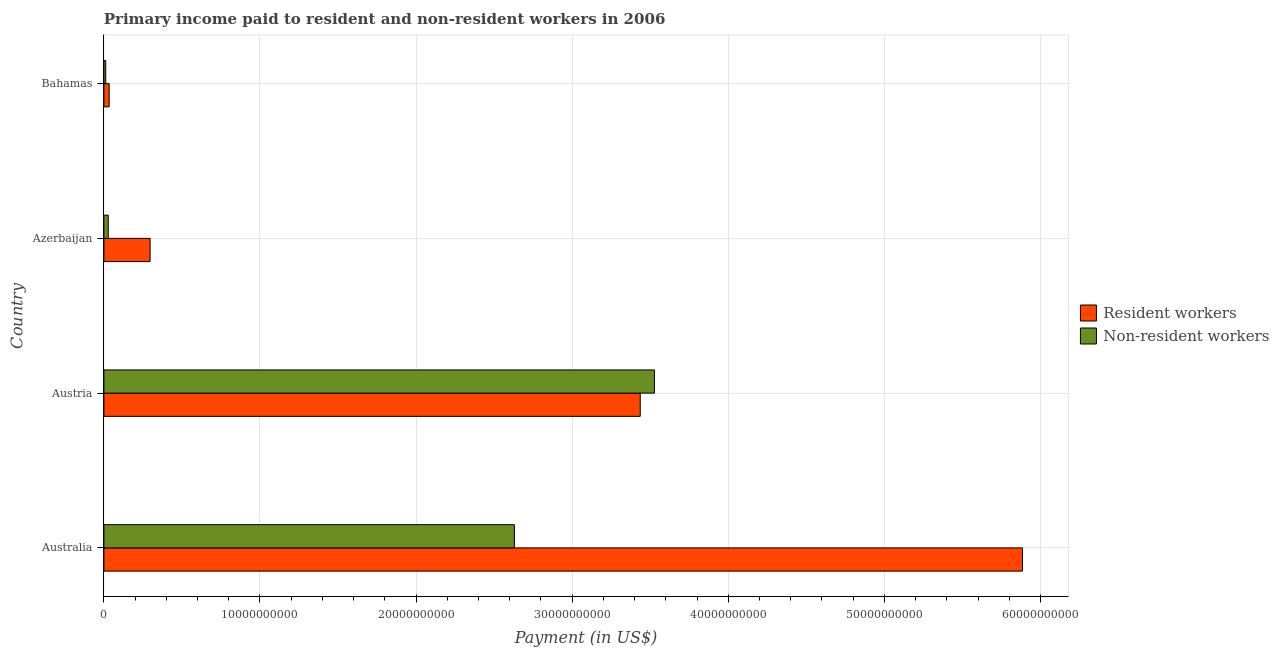Are the number of bars per tick equal to the number of legend labels?
Provide a short and direct response. Yes. How many bars are there on the 2nd tick from the bottom?
Offer a very short reply. 2. What is the label of the 4th group of bars from the top?
Your answer should be very brief. Australia. In how many cases, is the number of bars for a given country not equal to the number of legend labels?
Your answer should be compact. 0. What is the payment made to non-resident workers in Australia?
Your answer should be very brief. 2.63e+1. Across all countries, what is the maximum payment made to resident workers?
Provide a succinct answer. 5.88e+1. Across all countries, what is the minimum payment made to resident workers?
Provide a short and direct response. 3.37e+08. In which country was the payment made to resident workers maximum?
Keep it short and to the point. Australia. In which country was the payment made to resident workers minimum?
Offer a very short reply. Bahamas. What is the total payment made to resident workers in the graph?
Offer a very short reply. 9.65e+1. What is the difference between the payment made to non-resident workers in Australia and that in Austria?
Your answer should be very brief. -8.97e+09. What is the difference between the payment made to resident workers in Australia and the payment made to non-resident workers in Austria?
Your answer should be very brief. 2.36e+1. What is the average payment made to resident workers per country?
Make the answer very short. 2.41e+1. What is the difference between the payment made to resident workers and payment made to non-resident workers in Bahamas?
Provide a short and direct response. 2.18e+08. What is the ratio of the payment made to resident workers in Azerbaijan to that in Bahamas?
Offer a terse response. 8.78. Is the payment made to resident workers in Austria less than that in Azerbaijan?
Keep it short and to the point. No. Is the difference between the payment made to resident workers in Austria and Azerbaijan greater than the difference between the payment made to non-resident workers in Austria and Azerbaijan?
Give a very brief answer. No. What is the difference between the highest and the second highest payment made to resident workers?
Provide a succinct answer. 2.45e+1. What is the difference between the highest and the lowest payment made to non-resident workers?
Provide a succinct answer. 3.52e+1. Is the sum of the payment made to resident workers in Austria and Bahamas greater than the maximum payment made to non-resident workers across all countries?
Offer a terse response. No. What does the 2nd bar from the top in Bahamas represents?
Keep it short and to the point. Resident workers. What does the 1st bar from the bottom in Bahamas represents?
Offer a very short reply. Resident workers. How many bars are there?
Your answer should be compact. 8. Are all the bars in the graph horizontal?
Your answer should be very brief. Yes. How many countries are there in the graph?
Your answer should be compact. 4. What is the difference between two consecutive major ticks on the X-axis?
Make the answer very short. 1.00e+1. Does the graph contain grids?
Give a very brief answer. Yes. Where does the legend appear in the graph?
Offer a terse response. Center right. How are the legend labels stacked?
Keep it short and to the point. Vertical. What is the title of the graph?
Your answer should be compact. Primary income paid to resident and non-resident workers in 2006. Does "Central government" appear as one of the legend labels in the graph?
Offer a very short reply. No. What is the label or title of the X-axis?
Keep it short and to the point. Payment (in US$). What is the Payment (in US$) in Resident workers in Australia?
Offer a very short reply. 5.88e+1. What is the Payment (in US$) in Non-resident workers in Australia?
Give a very brief answer. 2.63e+1. What is the Payment (in US$) of Resident workers in Austria?
Your answer should be very brief. 3.44e+1. What is the Payment (in US$) in Non-resident workers in Austria?
Your answer should be compact. 3.53e+1. What is the Payment (in US$) in Resident workers in Azerbaijan?
Your answer should be very brief. 2.96e+09. What is the Payment (in US$) in Non-resident workers in Azerbaijan?
Your answer should be very brief. 2.80e+08. What is the Payment (in US$) of Resident workers in Bahamas?
Give a very brief answer. 3.37e+08. What is the Payment (in US$) in Non-resident workers in Bahamas?
Your response must be concise. 1.19e+08. Across all countries, what is the maximum Payment (in US$) in Resident workers?
Keep it short and to the point. 5.88e+1. Across all countries, what is the maximum Payment (in US$) in Non-resident workers?
Provide a short and direct response. 3.53e+1. Across all countries, what is the minimum Payment (in US$) of Resident workers?
Provide a succinct answer. 3.37e+08. Across all countries, what is the minimum Payment (in US$) of Non-resident workers?
Your answer should be compact. 1.19e+08. What is the total Payment (in US$) in Resident workers in the graph?
Make the answer very short. 9.65e+1. What is the total Payment (in US$) in Non-resident workers in the graph?
Offer a very short reply. 6.20e+1. What is the difference between the Payment (in US$) of Resident workers in Australia and that in Austria?
Your answer should be compact. 2.45e+1. What is the difference between the Payment (in US$) in Non-resident workers in Australia and that in Austria?
Provide a succinct answer. -8.97e+09. What is the difference between the Payment (in US$) of Resident workers in Australia and that in Azerbaijan?
Offer a very short reply. 5.59e+1. What is the difference between the Payment (in US$) of Non-resident workers in Australia and that in Azerbaijan?
Your response must be concise. 2.60e+1. What is the difference between the Payment (in US$) in Resident workers in Australia and that in Bahamas?
Provide a short and direct response. 5.85e+1. What is the difference between the Payment (in US$) of Non-resident workers in Australia and that in Bahamas?
Offer a very short reply. 2.62e+1. What is the difference between the Payment (in US$) of Resident workers in Austria and that in Azerbaijan?
Provide a succinct answer. 3.14e+1. What is the difference between the Payment (in US$) in Non-resident workers in Austria and that in Azerbaijan?
Make the answer very short. 3.50e+1. What is the difference between the Payment (in US$) in Resident workers in Austria and that in Bahamas?
Make the answer very short. 3.40e+1. What is the difference between the Payment (in US$) in Non-resident workers in Austria and that in Bahamas?
Ensure brevity in your answer.  3.52e+1. What is the difference between the Payment (in US$) in Resident workers in Azerbaijan and that in Bahamas?
Offer a terse response. 2.62e+09. What is the difference between the Payment (in US$) in Non-resident workers in Azerbaijan and that in Bahamas?
Ensure brevity in your answer.  1.61e+08. What is the difference between the Payment (in US$) of Resident workers in Australia and the Payment (in US$) of Non-resident workers in Austria?
Make the answer very short. 2.36e+1. What is the difference between the Payment (in US$) of Resident workers in Australia and the Payment (in US$) of Non-resident workers in Azerbaijan?
Provide a short and direct response. 5.86e+1. What is the difference between the Payment (in US$) in Resident workers in Australia and the Payment (in US$) in Non-resident workers in Bahamas?
Your answer should be compact. 5.87e+1. What is the difference between the Payment (in US$) of Resident workers in Austria and the Payment (in US$) of Non-resident workers in Azerbaijan?
Your response must be concise. 3.41e+1. What is the difference between the Payment (in US$) of Resident workers in Austria and the Payment (in US$) of Non-resident workers in Bahamas?
Your answer should be very brief. 3.42e+1. What is the difference between the Payment (in US$) in Resident workers in Azerbaijan and the Payment (in US$) in Non-resident workers in Bahamas?
Provide a short and direct response. 2.84e+09. What is the average Payment (in US$) of Resident workers per country?
Your answer should be compact. 2.41e+1. What is the average Payment (in US$) in Non-resident workers per country?
Your answer should be compact. 1.55e+1. What is the difference between the Payment (in US$) in Resident workers and Payment (in US$) in Non-resident workers in Australia?
Offer a very short reply. 3.25e+1. What is the difference between the Payment (in US$) of Resident workers and Payment (in US$) of Non-resident workers in Austria?
Provide a succinct answer. -9.10e+08. What is the difference between the Payment (in US$) in Resident workers and Payment (in US$) in Non-resident workers in Azerbaijan?
Your answer should be compact. 2.68e+09. What is the difference between the Payment (in US$) of Resident workers and Payment (in US$) of Non-resident workers in Bahamas?
Keep it short and to the point. 2.18e+08. What is the ratio of the Payment (in US$) in Resident workers in Australia to that in Austria?
Ensure brevity in your answer.  1.71. What is the ratio of the Payment (in US$) of Non-resident workers in Australia to that in Austria?
Offer a very short reply. 0.75. What is the ratio of the Payment (in US$) of Resident workers in Australia to that in Azerbaijan?
Provide a short and direct response. 19.88. What is the ratio of the Payment (in US$) of Non-resident workers in Australia to that in Azerbaijan?
Your answer should be compact. 93.92. What is the ratio of the Payment (in US$) of Resident workers in Australia to that in Bahamas?
Your answer should be compact. 174.42. What is the ratio of the Payment (in US$) in Non-resident workers in Australia to that in Bahamas?
Offer a very short reply. 220.27. What is the ratio of the Payment (in US$) of Resident workers in Austria to that in Azerbaijan?
Your response must be concise. 11.61. What is the ratio of the Payment (in US$) of Non-resident workers in Austria to that in Azerbaijan?
Your answer should be very brief. 125.96. What is the ratio of the Payment (in US$) in Resident workers in Austria to that in Bahamas?
Offer a very short reply. 101.84. What is the ratio of the Payment (in US$) of Non-resident workers in Austria to that in Bahamas?
Ensure brevity in your answer.  295.41. What is the ratio of the Payment (in US$) of Resident workers in Azerbaijan to that in Bahamas?
Your answer should be very brief. 8.78. What is the ratio of the Payment (in US$) in Non-resident workers in Azerbaijan to that in Bahamas?
Provide a succinct answer. 2.35. What is the difference between the highest and the second highest Payment (in US$) in Resident workers?
Provide a succinct answer. 2.45e+1. What is the difference between the highest and the second highest Payment (in US$) in Non-resident workers?
Make the answer very short. 8.97e+09. What is the difference between the highest and the lowest Payment (in US$) in Resident workers?
Keep it short and to the point. 5.85e+1. What is the difference between the highest and the lowest Payment (in US$) in Non-resident workers?
Provide a short and direct response. 3.52e+1. 